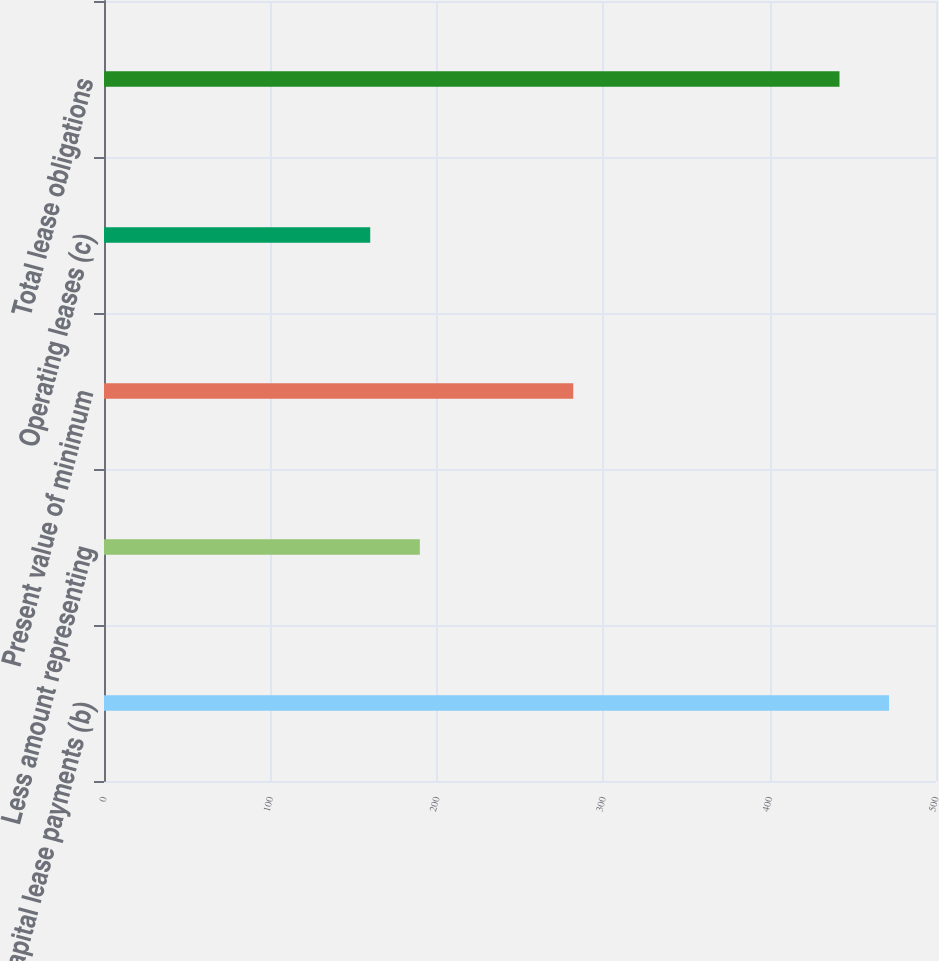Convert chart. <chart><loc_0><loc_0><loc_500><loc_500><bar_chart><fcel>Capital lease payments (b)<fcel>Less amount representing<fcel>Present value of minimum<fcel>Operating leases (c)<fcel>Total lease obligations<nl><fcel>471.8<fcel>189.8<fcel>282<fcel>160<fcel>442<nl></chart> 